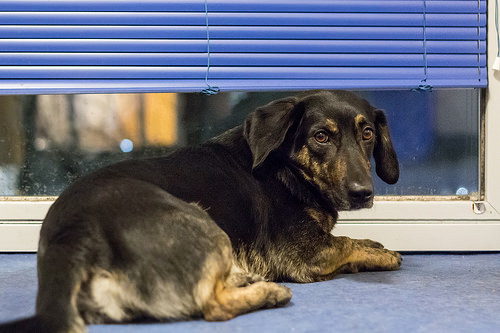<image>
Is the blinds behind the dog? Yes. From this viewpoint, the blinds is positioned behind the dog, with the dog partially or fully occluding the blinds. 